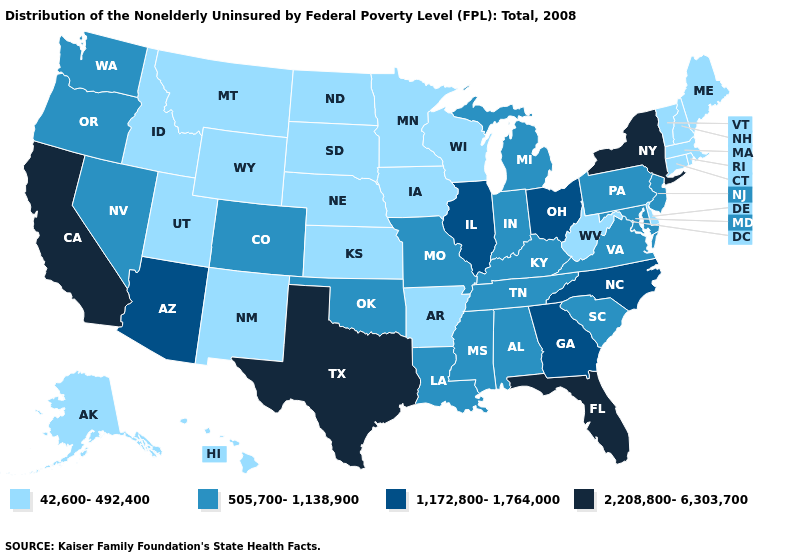Name the states that have a value in the range 2,208,800-6,303,700?
Keep it brief. California, Florida, New York, Texas. Name the states that have a value in the range 42,600-492,400?
Write a very short answer. Alaska, Arkansas, Connecticut, Delaware, Hawaii, Idaho, Iowa, Kansas, Maine, Massachusetts, Minnesota, Montana, Nebraska, New Hampshire, New Mexico, North Dakota, Rhode Island, South Dakota, Utah, Vermont, West Virginia, Wisconsin, Wyoming. Among the states that border Massachusetts , which have the lowest value?
Write a very short answer. Connecticut, New Hampshire, Rhode Island, Vermont. Is the legend a continuous bar?
Keep it brief. No. What is the lowest value in the West?
Answer briefly. 42,600-492,400. Does Vermont have the lowest value in the USA?
Quick response, please. Yes. Among the states that border Massachusetts , does New York have the lowest value?
Give a very brief answer. No. Name the states that have a value in the range 2,208,800-6,303,700?
Give a very brief answer. California, Florida, New York, Texas. Name the states that have a value in the range 42,600-492,400?
Short answer required. Alaska, Arkansas, Connecticut, Delaware, Hawaii, Idaho, Iowa, Kansas, Maine, Massachusetts, Minnesota, Montana, Nebraska, New Hampshire, New Mexico, North Dakota, Rhode Island, South Dakota, Utah, Vermont, West Virginia, Wisconsin, Wyoming. What is the value of Wyoming?
Short answer required. 42,600-492,400. What is the value of Arkansas?
Answer briefly. 42,600-492,400. What is the value of Georgia?
Answer briefly. 1,172,800-1,764,000. Name the states that have a value in the range 2,208,800-6,303,700?
Be succinct. California, Florida, New York, Texas. What is the lowest value in states that border Arizona?
Answer briefly. 42,600-492,400. Does the first symbol in the legend represent the smallest category?
Keep it brief. Yes. 